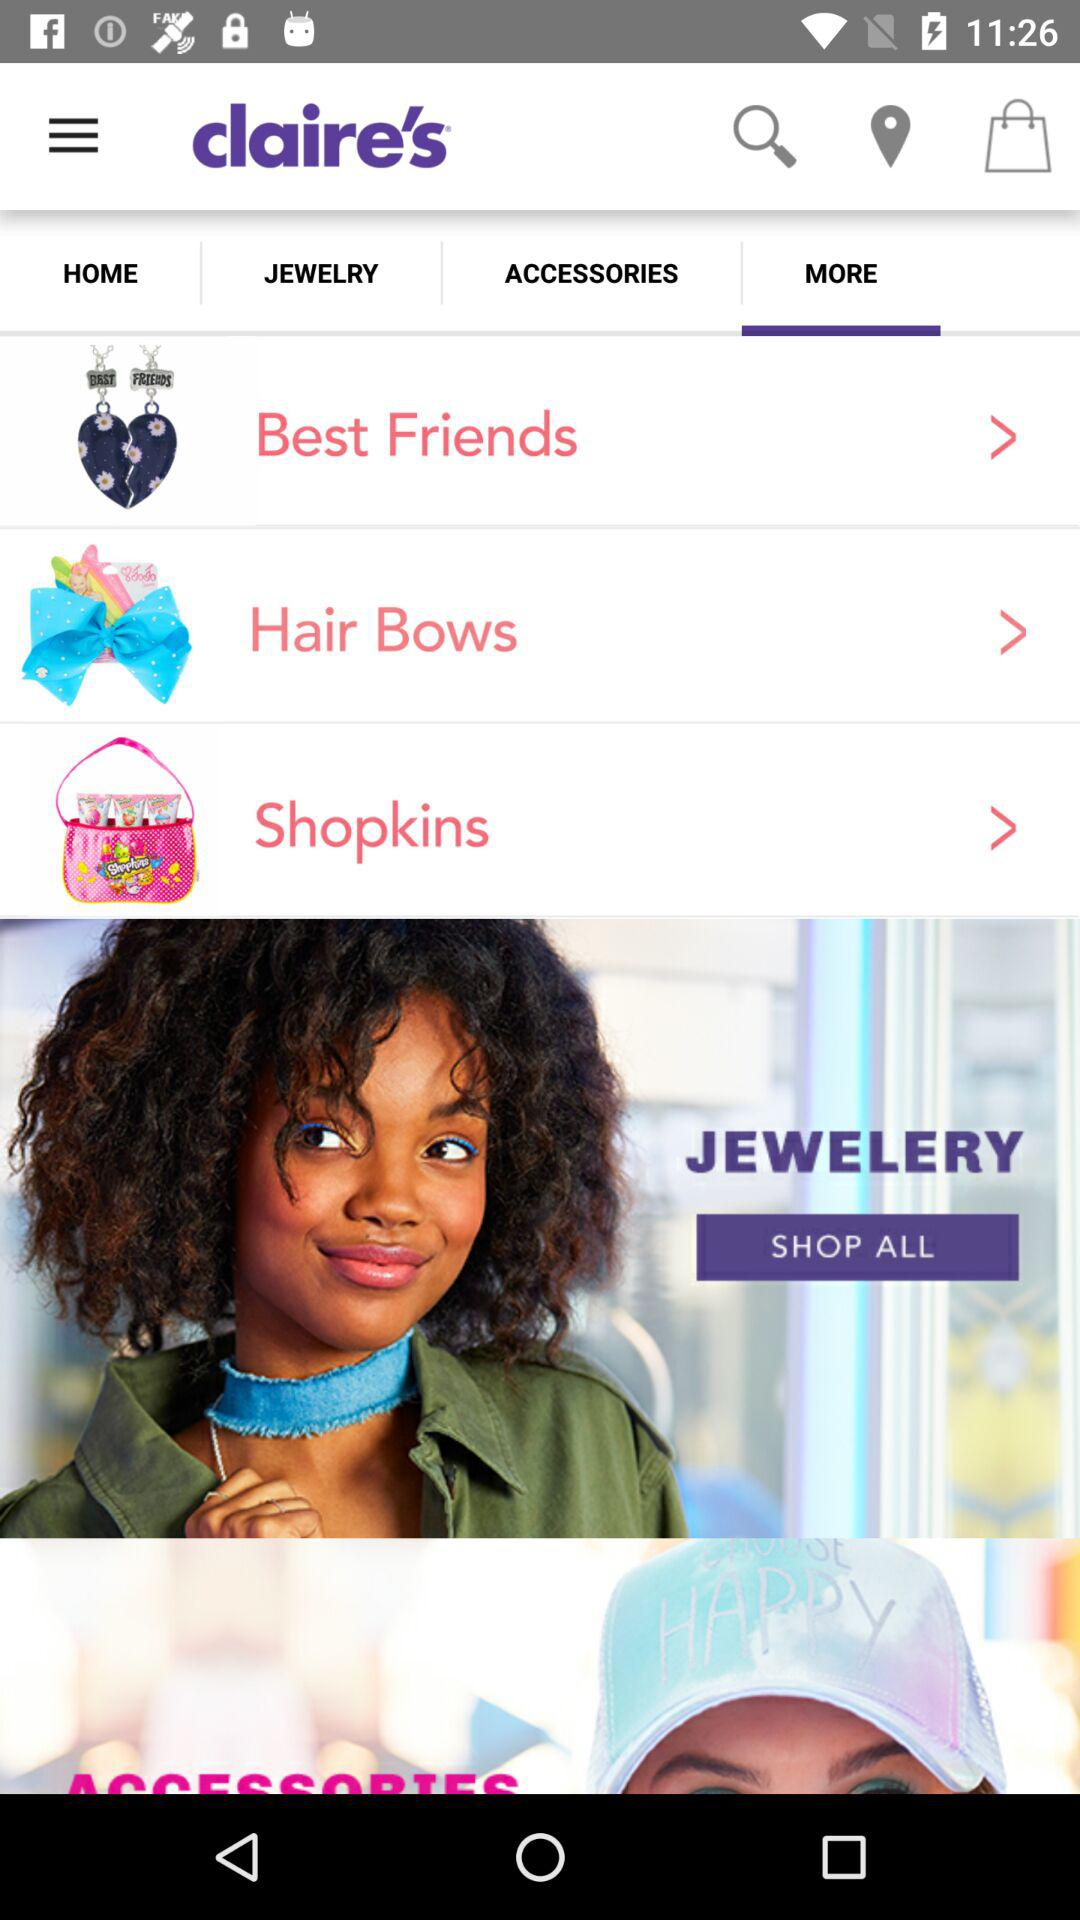What is the name of the application? The name of the application is "claire's". 